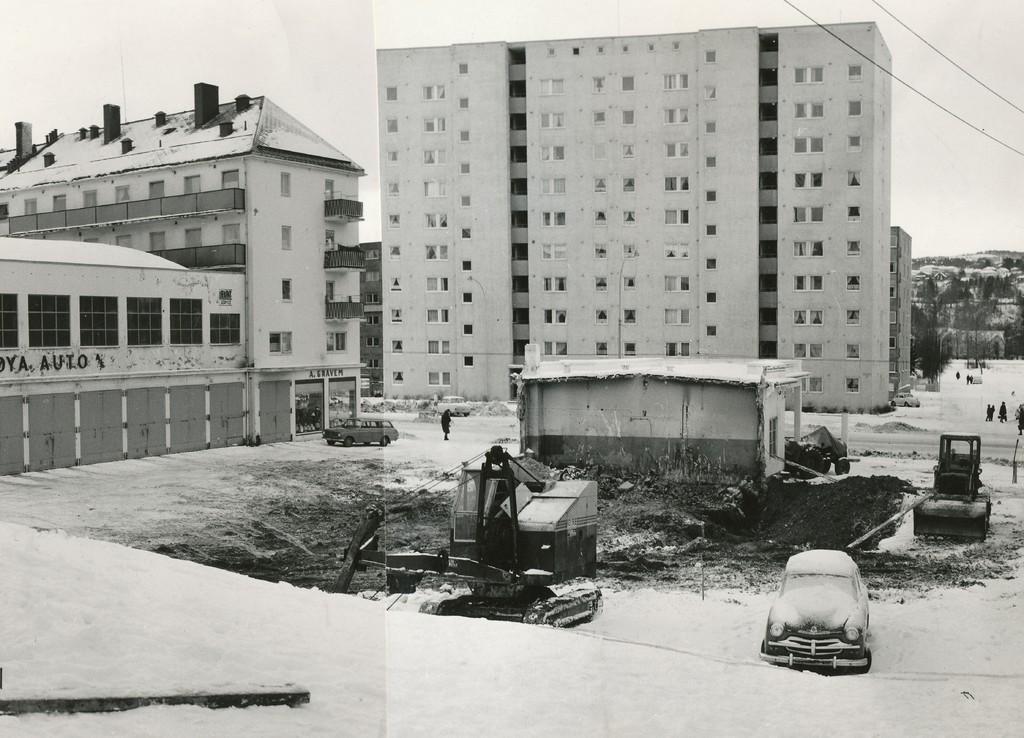How would you summarize this image in a sentence or two? This picture shows few buildings and we see couple of cars and couple of cranes and we see few people standing here and there and a cloudy sky. 